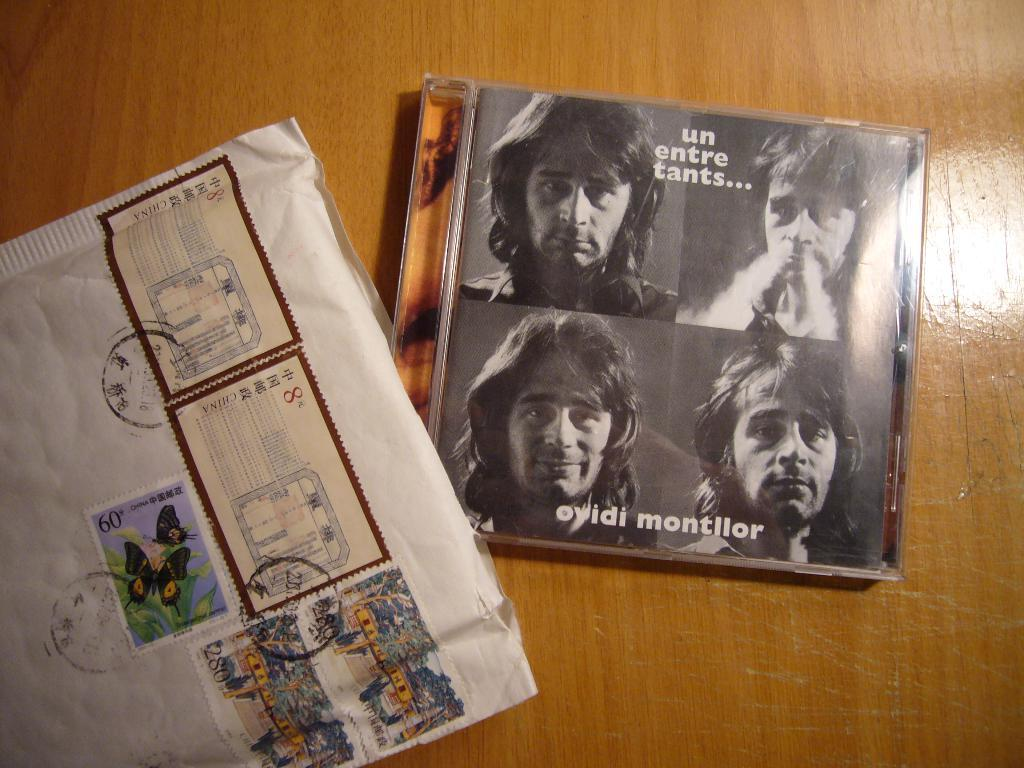What type of surface is visible in the image? There is a wooden surface in the image. What objects are placed on the wooden surface? There is a box and an envelope with stamps on the wooden surface. What is depicted on the box? The box has a collage picture of a person on it. What color is the sweater worn by the person in the collage picture on the box? There is no sweater visible in the image, as the focus is on the collage picture of a person on the box. 